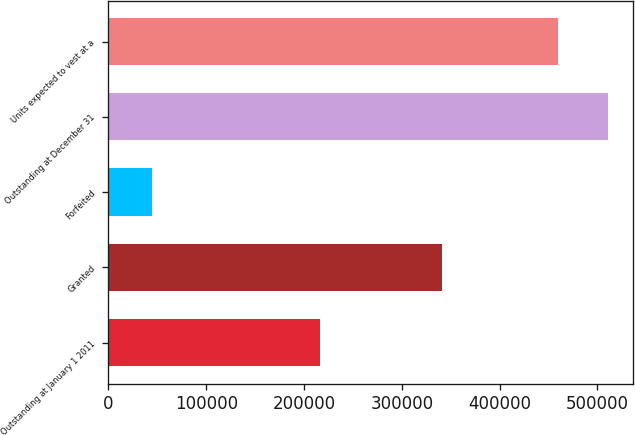Convert chart. <chart><loc_0><loc_0><loc_500><loc_500><bar_chart><fcel>Outstanding at January 1 2011<fcel>Granted<fcel>Forfeited<fcel>Outstanding at December 31<fcel>Units expected to vest at a<nl><fcel>216251<fcel>340750<fcel>44680<fcel>510681<fcel>459613<nl></chart> 